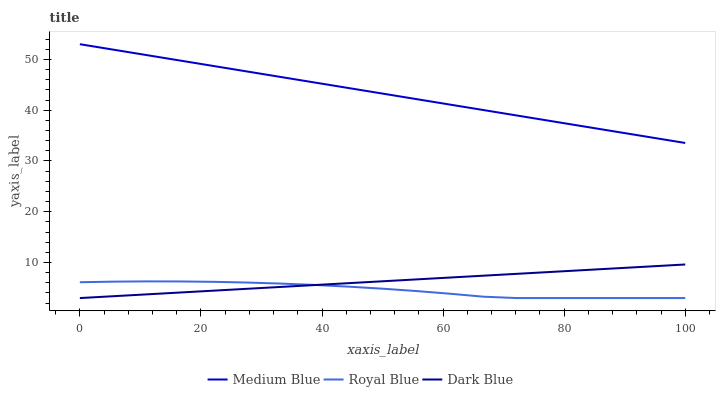Does Royal Blue have the minimum area under the curve?
Answer yes or no. Yes. Does Medium Blue have the maximum area under the curve?
Answer yes or no. Yes. Does Dark Blue have the minimum area under the curve?
Answer yes or no. No. Does Dark Blue have the maximum area under the curve?
Answer yes or no. No. Is Dark Blue the smoothest?
Answer yes or no. Yes. Is Royal Blue the roughest?
Answer yes or no. Yes. Is Medium Blue the smoothest?
Answer yes or no. No. Is Medium Blue the roughest?
Answer yes or no. No. Does Medium Blue have the lowest value?
Answer yes or no. No. Does Dark Blue have the highest value?
Answer yes or no. No. Is Dark Blue less than Medium Blue?
Answer yes or no. Yes. Is Medium Blue greater than Dark Blue?
Answer yes or no. Yes. Does Dark Blue intersect Medium Blue?
Answer yes or no. No. 